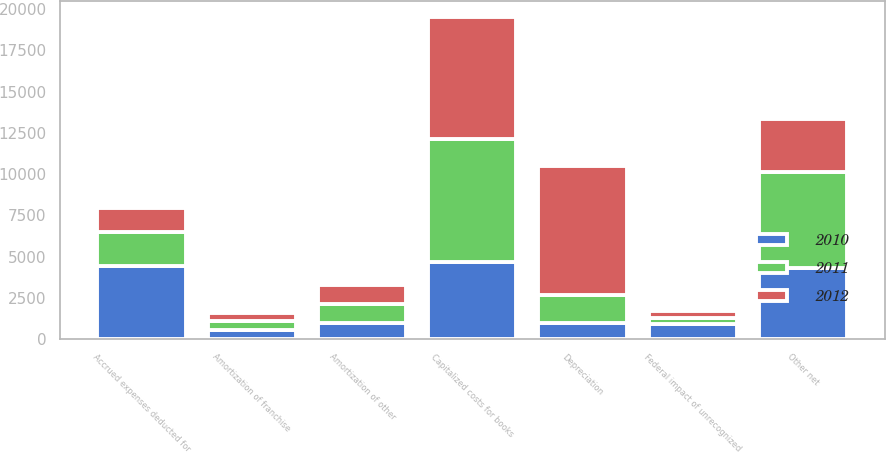Convert chart. <chart><loc_0><loc_0><loc_500><loc_500><stacked_bar_chart><ecel><fcel>Amortization of franchise<fcel>Amortization of other<fcel>Accrued expenses deducted for<fcel>Capitalized costs for books<fcel>Depreciation<fcel>Federal impact of unrecognized<fcel>Other net<nl><fcel>2012<fcel>514<fcel>1180<fcel>1444.5<fcel>7395<fcel>7813<fcel>478<fcel>3253<nl><fcel>2011<fcel>514<fcel>1142<fcel>2076<fcel>7448<fcel>1709<fcel>331<fcel>5787<nl><fcel>2010<fcel>570<fcel>961<fcel>4423<fcel>4693<fcel>951<fcel>921<fcel>4314<nl></chart> 